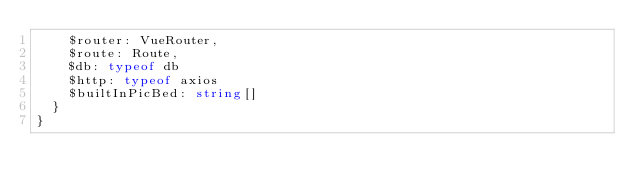Convert code to text. <code><loc_0><loc_0><loc_500><loc_500><_TypeScript_>    $router: VueRouter,
    $route: Route,
    $db: typeof db
    $http: typeof axios
    $builtInPicBed: string[]
  }
}
</code> 